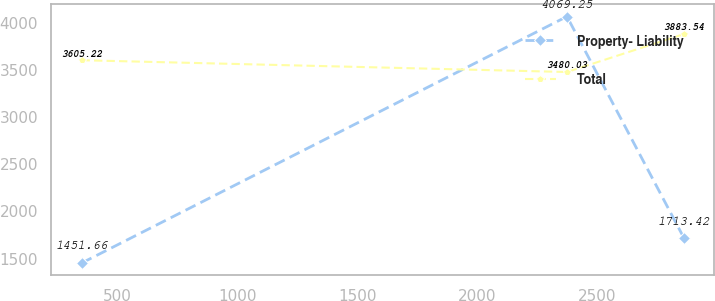Convert chart. <chart><loc_0><loc_0><loc_500><loc_500><line_chart><ecel><fcel>Property- Liability<fcel>Total<nl><fcel>349.56<fcel>1451.66<fcel>3605.22<nl><fcel>2376.12<fcel>4069.25<fcel>3480.03<nl><fcel>2865.41<fcel>1713.42<fcel>3883.54<nl></chart> 